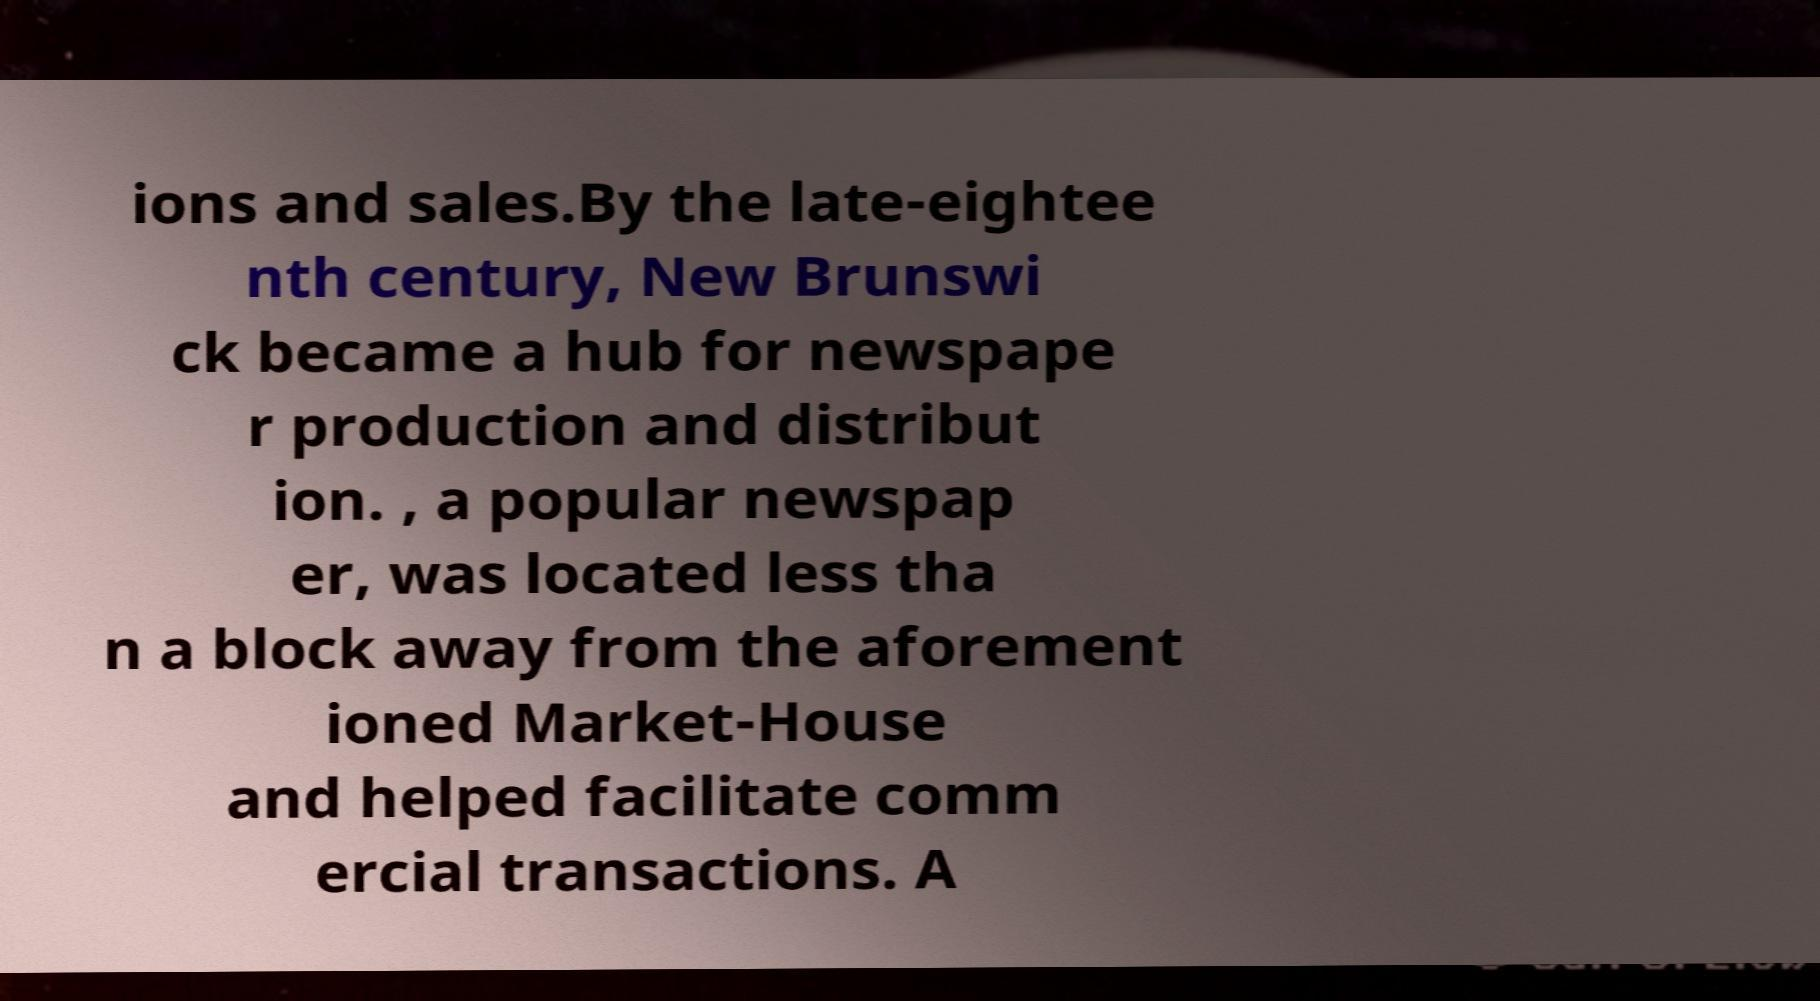There's text embedded in this image that I need extracted. Can you transcribe it verbatim? ions and sales.By the late-eightee nth century, New Brunswi ck became a hub for newspape r production and distribut ion. , a popular newspap er, was located less tha n a block away from the aforement ioned Market-House and helped facilitate comm ercial transactions. A 